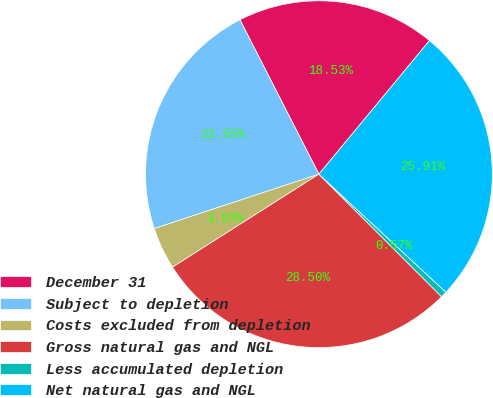Convert chart to OTSL. <chart><loc_0><loc_0><loc_500><loc_500><pie_chart><fcel>December 31<fcel>Subject to depletion<fcel>Costs excluded from depletion<fcel>Gross natural gas and NGL<fcel>Less accumulated depletion<fcel>Net natural gas and NGL<nl><fcel>18.53%<fcel>22.55%<fcel>3.93%<fcel>28.5%<fcel>0.57%<fcel>25.91%<nl></chart> 